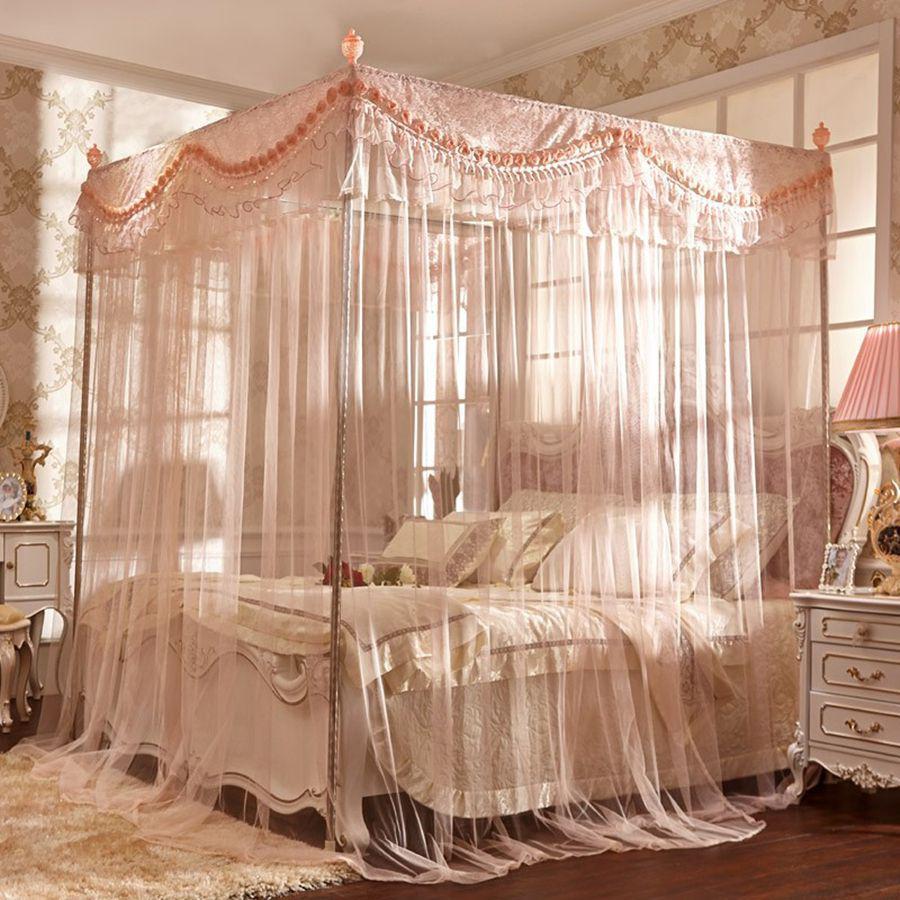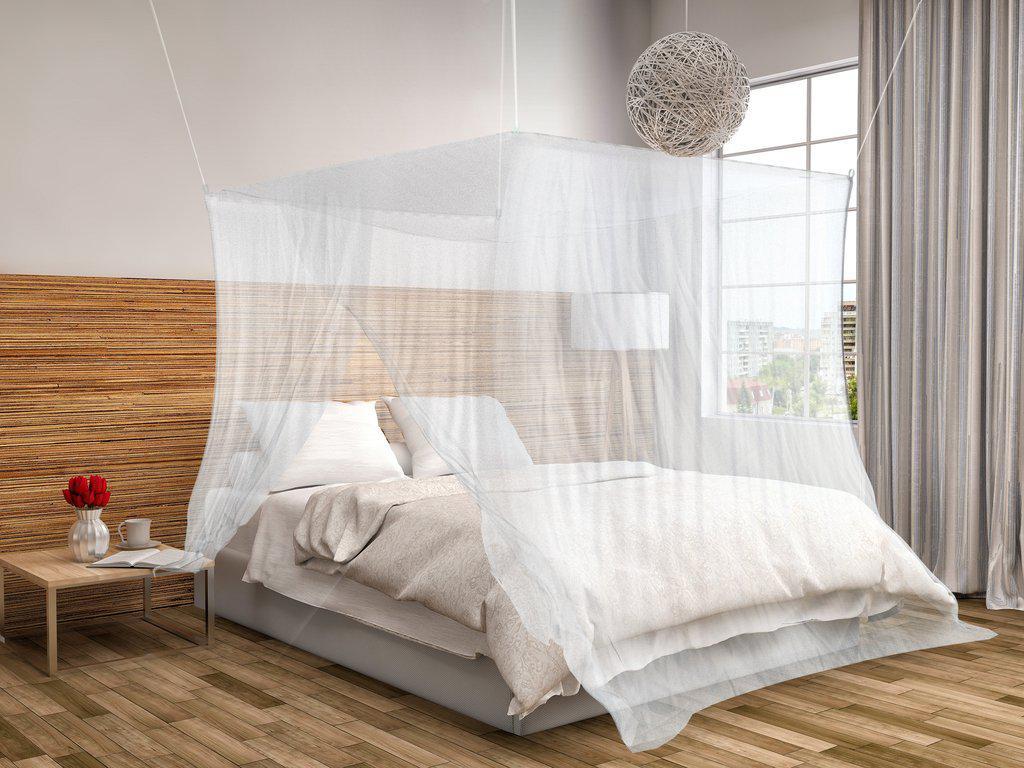The first image is the image on the left, the second image is the image on the right. Evaluate the accuracy of this statement regarding the images: "One image shows a ceiling-suspended gauzy white canopy that hangs over the middle of a bed in a cone shape that extends around most of the bed.". Is it true? Answer yes or no. No. 